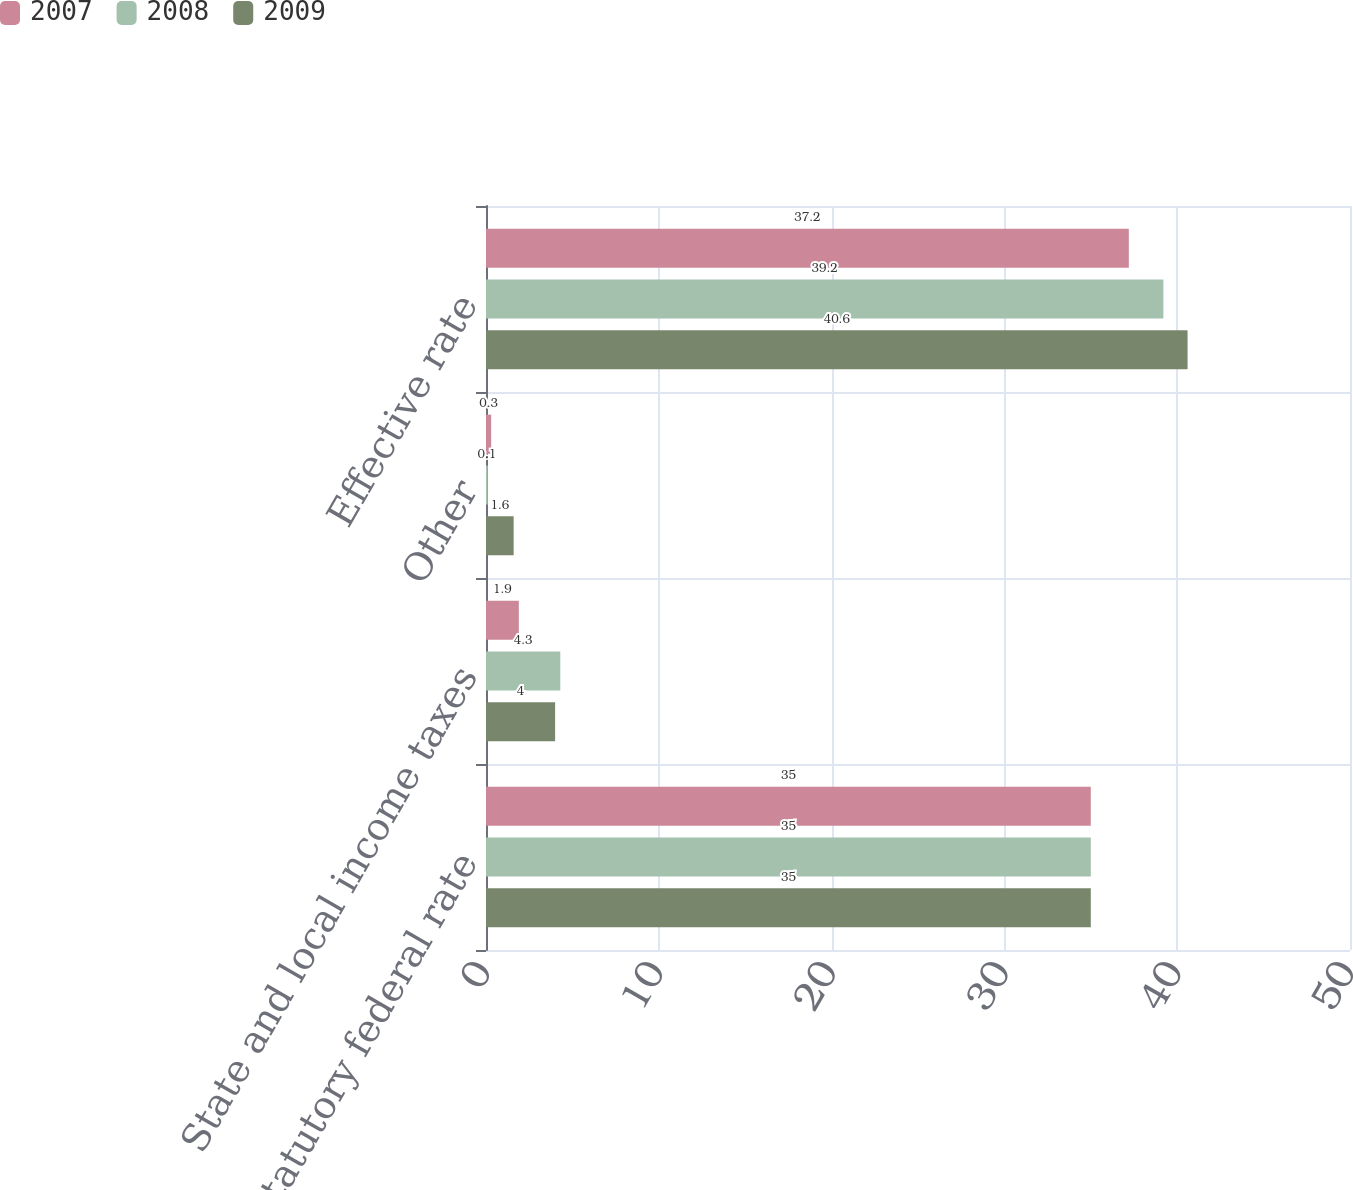<chart> <loc_0><loc_0><loc_500><loc_500><stacked_bar_chart><ecel><fcel>Statutory federal rate<fcel>State and local income taxes<fcel>Other<fcel>Effective rate<nl><fcel>2007<fcel>35<fcel>1.9<fcel>0.3<fcel>37.2<nl><fcel>2008<fcel>35<fcel>4.3<fcel>0.1<fcel>39.2<nl><fcel>2009<fcel>35<fcel>4<fcel>1.6<fcel>40.6<nl></chart> 